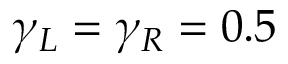<formula> <loc_0><loc_0><loc_500><loc_500>\gamma _ { L } = \gamma _ { R } = 0 . 5</formula> 